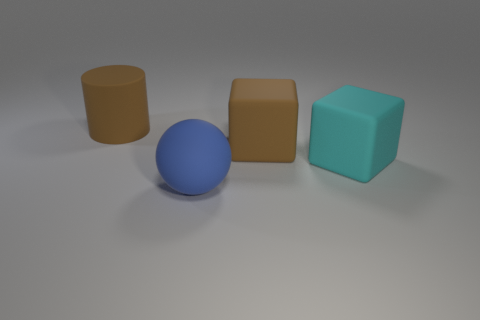Add 2 large cyan rubber objects. How many objects exist? 6 Subtract all balls. How many objects are left? 3 Subtract 1 blue spheres. How many objects are left? 3 Subtract all big brown things. Subtract all big metal things. How many objects are left? 2 Add 1 brown blocks. How many brown blocks are left? 2 Add 2 large cyan objects. How many large cyan objects exist? 3 